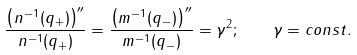Convert formula to latex. <formula><loc_0><loc_0><loc_500><loc_500>\frac { \left ( n ^ { - 1 } ( q _ { + } ) \right ) ^ { \prime \prime } } { n ^ { - 1 } ( q _ { + } ) } = \frac { \left ( m ^ { - 1 } ( q _ { - } ) \right ) ^ { \prime \prime } } { m ^ { - 1 } ( q _ { - } ) } = \gamma ^ { 2 } ; \quad \gamma = c o n s t .</formula> 